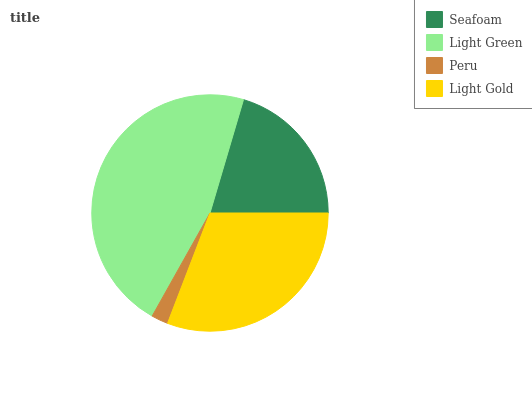Is Peru the minimum?
Answer yes or no. Yes. Is Light Green the maximum?
Answer yes or no. Yes. Is Light Green the minimum?
Answer yes or no. No. Is Peru the maximum?
Answer yes or no. No. Is Light Green greater than Peru?
Answer yes or no. Yes. Is Peru less than Light Green?
Answer yes or no. Yes. Is Peru greater than Light Green?
Answer yes or no. No. Is Light Green less than Peru?
Answer yes or no. No. Is Light Gold the high median?
Answer yes or no. Yes. Is Seafoam the low median?
Answer yes or no. Yes. Is Light Green the high median?
Answer yes or no. No. Is Light Gold the low median?
Answer yes or no. No. 